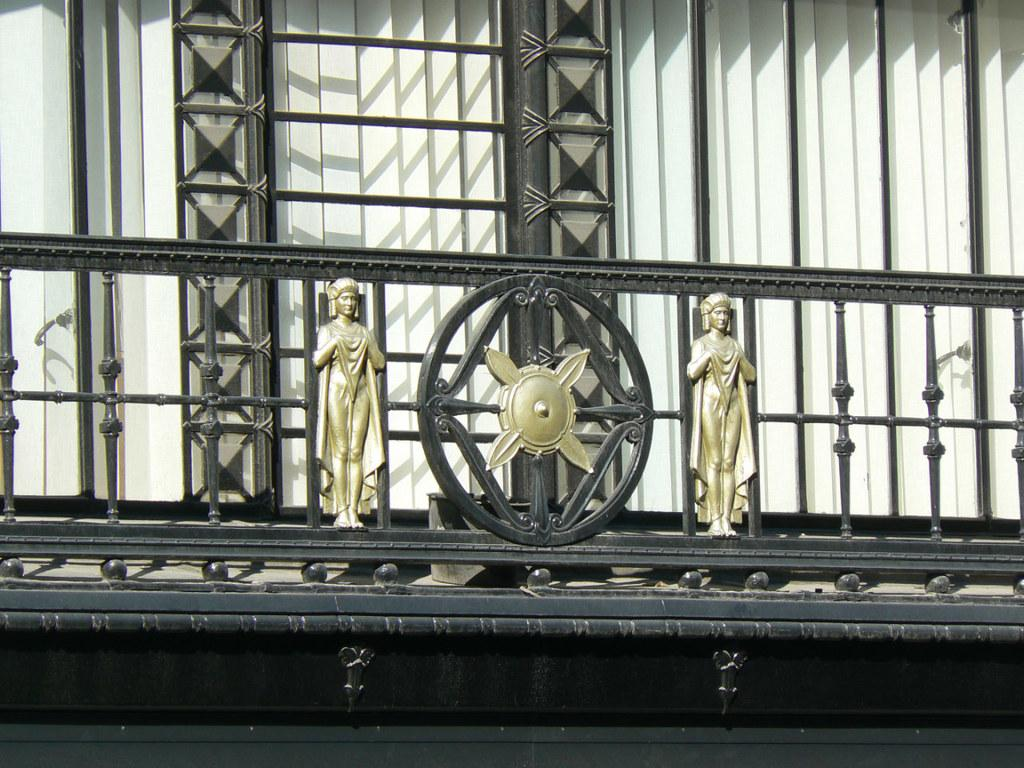What type of structure is visible in the image? There is a building in the image. What can be seen covering the windows of the building? Window blinds are present in the image. Are there any decorative elements in the image? Yes, there are two statues in the image. Is there any quicksand visible in the image? No, there is no quicksand present in the image. What type of rest can be seen in the image? The image does not depict any type of rest or resting area. 